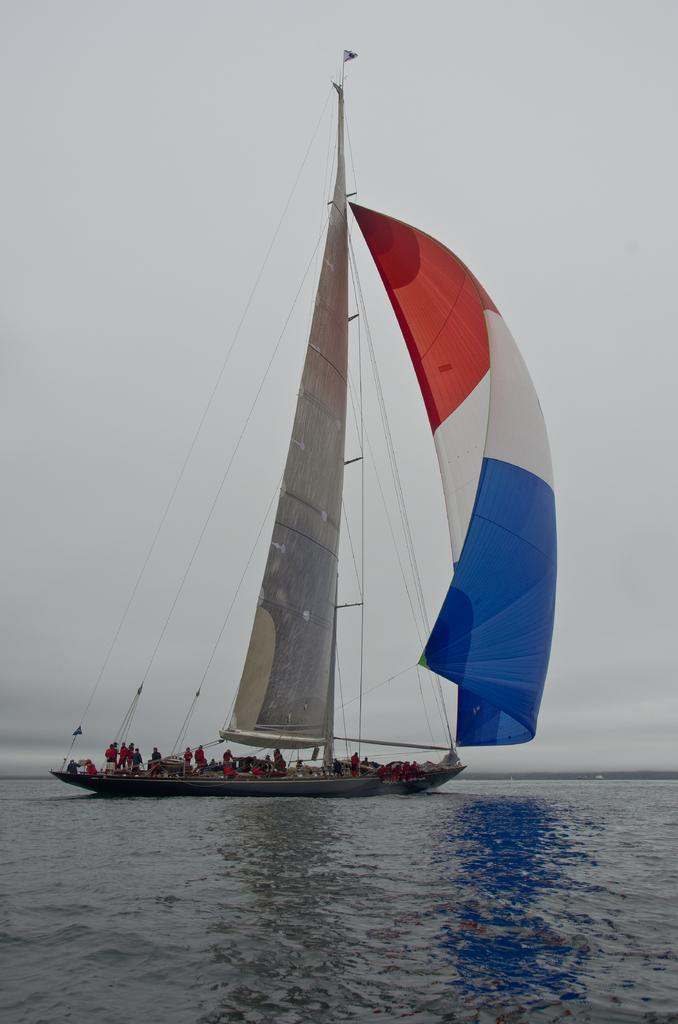What are the people in the image doing? The people in the image are on a boat. What is the primary setting of the image? There is water visible in the image. What can be seen in the background of the image? There is sky visible in the background of the image. What type of tail can be seen wagging in the image? There is no tail present in the image. What is the aftermath of the storm in the image? There is no mention of a storm or any aftermath in the image. 